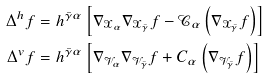Convert formula to latex. <formula><loc_0><loc_0><loc_500><loc_500>\Delta ^ { h } f & = h ^ { \bar { \gamma } \alpha } \left [ \nabla _ { \mathcal { X } _ { \alpha } } \nabla _ { \mathcal { X } _ { \bar { \gamma } } } f - \mathcal { C } _ { \alpha } \left ( \nabla _ { \mathcal { X } _ { \bar { \gamma } } } f \right ) \right ] \\ \Delta ^ { v } f & = h ^ { \bar { \gamma } \alpha } \left [ \nabla _ { \mathcal { V } _ { \alpha } } \nabla _ { \mathcal { V } _ { \bar { \gamma } } } f + C _ { \alpha } \left ( \nabla _ { \mathcal { V } _ { \bar { \gamma } } } f \right ) \right ]</formula> 